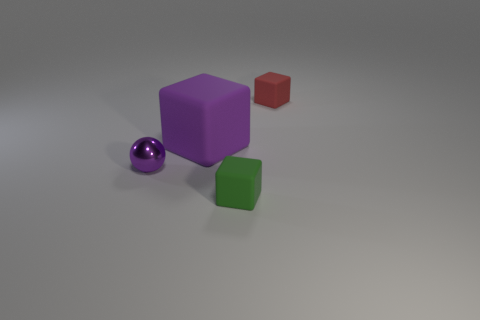Add 1 purple metal objects. How many objects exist? 5 Subtract all spheres. How many objects are left? 3 Subtract 0 red cylinders. How many objects are left? 4 Subtract all small green rubber cubes. Subtract all small purple cubes. How many objects are left? 3 Add 2 small green matte things. How many small green matte things are left? 3 Add 1 tiny matte objects. How many tiny matte objects exist? 3 